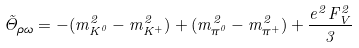<formula> <loc_0><loc_0><loc_500><loc_500>\tilde { \Theta } _ { \rho \omega } = - ( m ^ { 2 } _ { K ^ { 0 } } - m ^ { 2 } _ { K ^ { + } } ) + ( m ^ { 2 } _ { \pi ^ { 0 } } - m ^ { 2 } _ { \pi ^ { + } } ) + \frac { e ^ { 2 } F _ { V } ^ { 2 } } { 3 }</formula> 